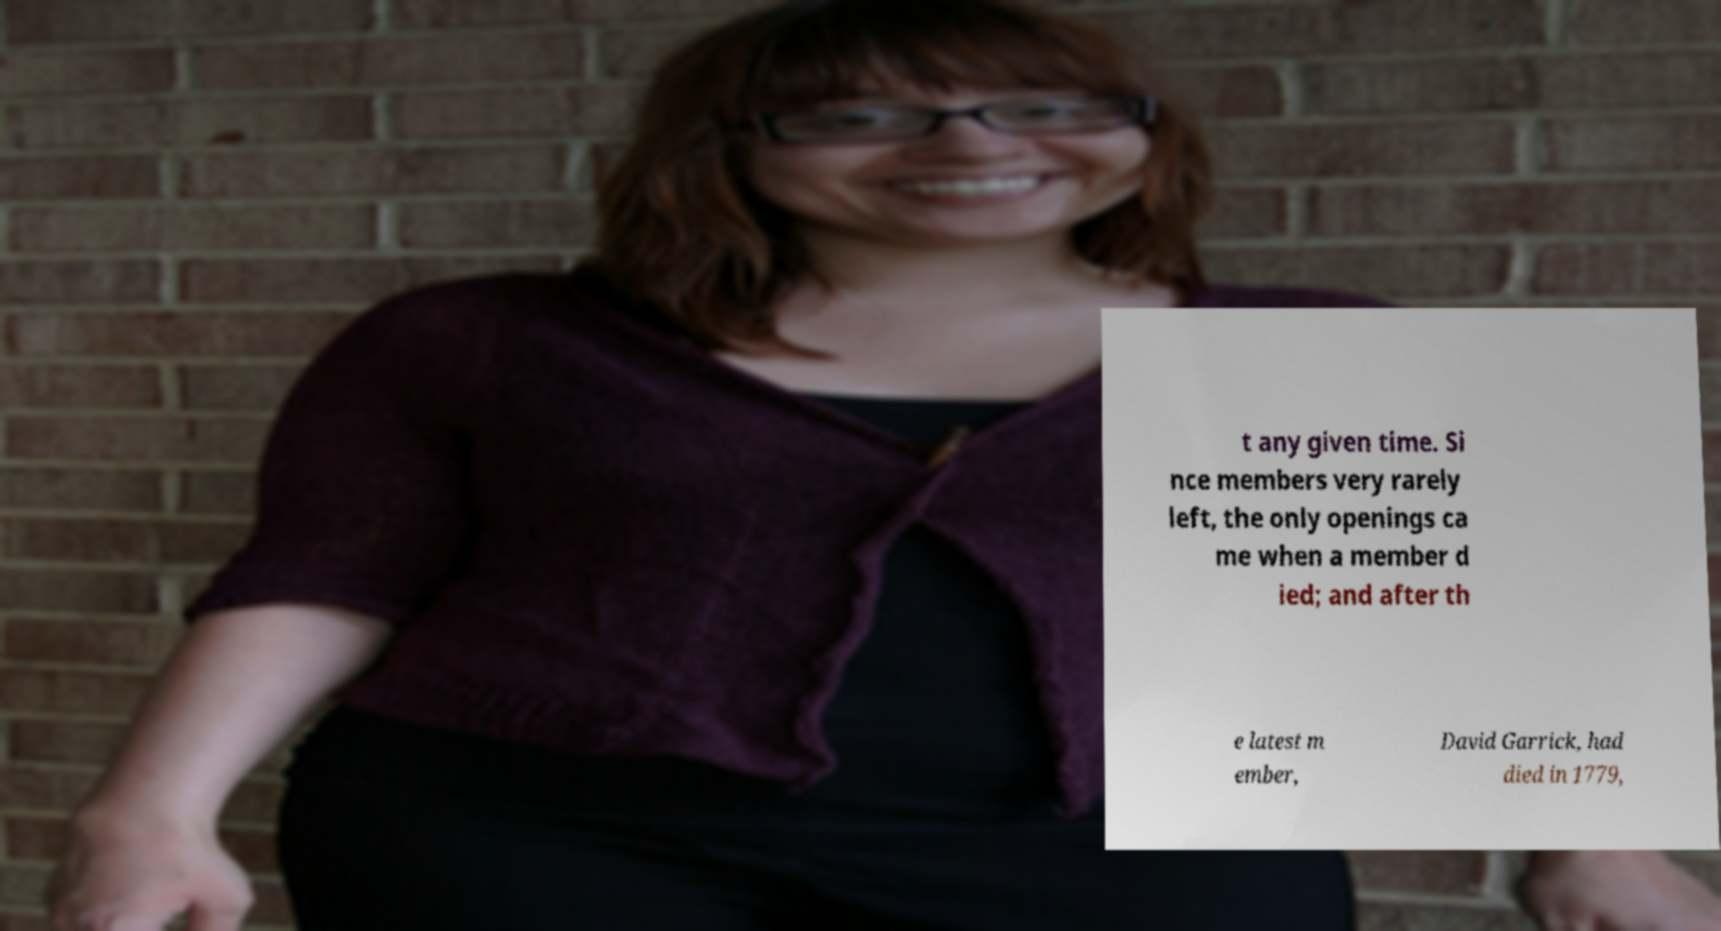Please read and relay the text visible in this image. What does it say? t any given time. Si nce members very rarely left, the only openings ca me when a member d ied; and after th e latest m ember, David Garrick, had died in 1779, 